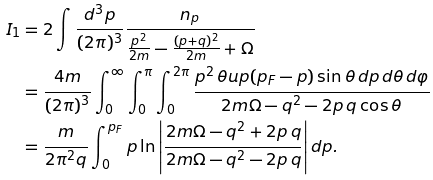Convert formula to latex. <formula><loc_0><loc_0><loc_500><loc_500>I _ { 1 } & = 2 \int \frac { d ^ { 3 } p } { ( 2 \pi ) ^ { 3 } } \frac { n _ { p } } { \frac { p ^ { 2 } } { 2 m } - \frac { ( p + q ) ^ { 2 } } { 2 m } + \Omega } \\ & = \frac { 4 m } { ( 2 \pi ) ^ { 3 } } \int _ { 0 } ^ { \infty } \int _ { 0 } ^ { \pi } \int _ { 0 } ^ { 2 \pi } \frac { p ^ { 2 } \, \theta u p ( p _ { F } - p ) \sin \theta \, d p \, d \theta \, d \varphi } { 2 m \Omega - q ^ { 2 } - 2 p \, q \cos \theta } \\ & = \frac { m } { 2 \pi ^ { 2 } q } \int _ { 0 } ^ { p _ { F } } p \ln \left | \frac { 2 m \Omega - q ^ { 2 } + 2 p \, q } { 2 m \Omega - q ^ { 2 } - 2 p \, q } \right | d p .</formula> 